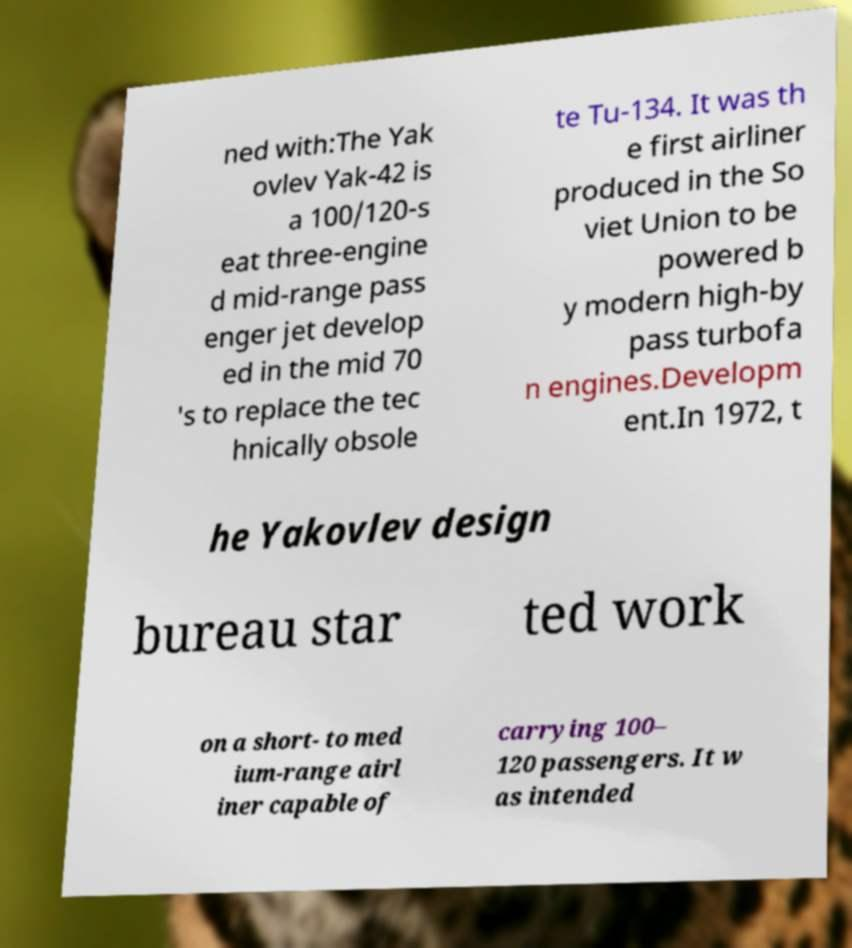What messages or text are displayed in this image? I need them in a readable, typed format. ned with:The Yak ovlev Yak-42 is a 100/120-s eat three-engine d mid-range pass enger jet develop ed in the mid 70 's to replace the tec hnically obsole te Tu-134. It was th e first airliner produced in the So viet Union to be powered b y modern high-by pass turbofa n engines.Developm ent.In 1972, t he Yakovlev design bureau star ted work on a short- to med ium-range airl iner capable of carrying 100– 120 passengers. It w as intended 